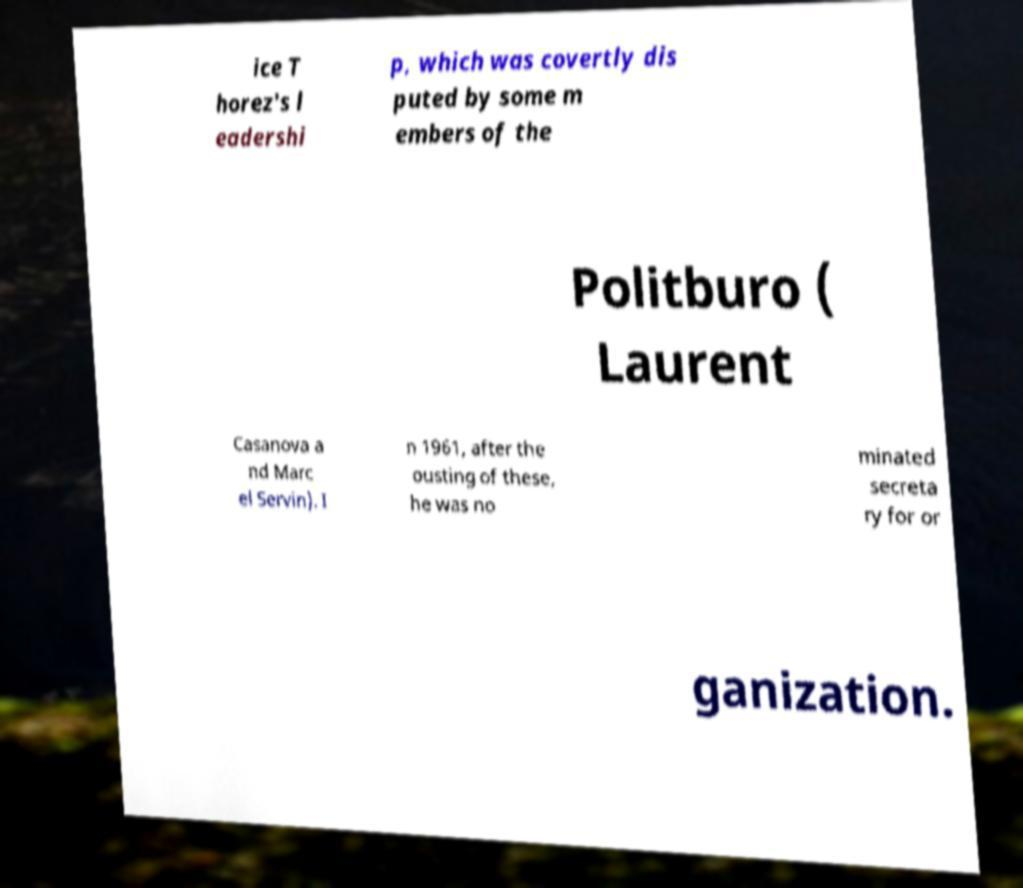For documentation purposes, I need the text within this image transcribed. Could you provide that? ice T horez's l eadershi p, which was covertly dis puted by some m embers of the Politburo ( Laurent Casanova a nd Marc el Servin). I n 1961, after the ousting of these, he was no minated secreta ry for or ganization. 